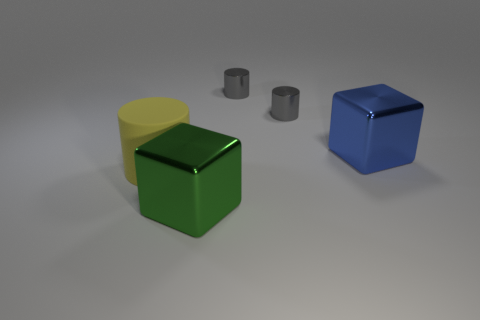What number of other things are there of the same material as the blue block
Ensure brevity in your answer.  3. Are there more purple cylinders than blue metal things?
Ensure brevity in your answer.  No. Is the green object the same shape as the blue thing?
Your answer should be compact. Yes. What material is the cylinder in front of the large metallic thing on the right side of the big green object?
Your answer should be compact. Rubber. Does the yellow cylinder have the same size as the blue metal cube?
Keep it short and to the point. Yes. There is a large object behind the large matte cylinder; is there a matte cylinder to the left of it?
Make the answer very short. Yes. The shiny object in front of the large blue thing has what shape?
Ensure brevity in your answer.  Cube. There is a big block left of the big metallic object that is behind the yellow matte cylinder; how many yellow cylinders are behind it?
Give a very brief answer. 1. How big is the metal block to the right of the large block on the left side of the big blue cube?
Your answer should be compact. Large. What number of other large blue things are made of the same material as the blue thing?
Your answer should be compact. 0. 